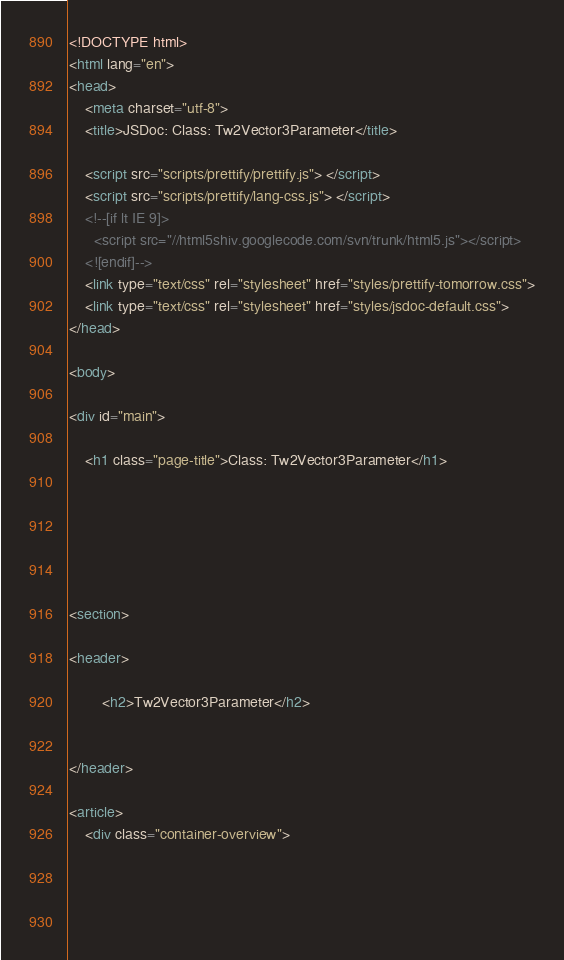<code> <loc_0><loc_0><loc_500><loc_500><_HTML_><!DOCTYPE html>
<html lang="en">
<head>
    <meta charset="utf-8">
    <title>JSDoc: Class: Tw2Vector3Parameter</title>

    <script src="scripts/prettify/prettify.js"> </script>
    <script src="scripts/prettify/lang-css.js"> </script>
    <!--[if lt IE 9]>
      <script src="//html5shiv.googlecode.com/svn/trunk/html5.js"></script>
    <![endif]-->
    <link type="text/css" rel="stylesheet" href="styles/prettify-tomorrow.css">
    <link type="text/css" rel="stylesheet" href="styles/jsdoc-default.css">
</head>

<body>

<div id="main">

    <h1 class="page-title">Class: Tw2Vector3Parameter</h1>

    




<section>

<header>
    
        <h2>Tw2Vector3Parameter</h2>
        
    
</header>

<article>
    <div class="container-overview">
    
        

    
</code> 